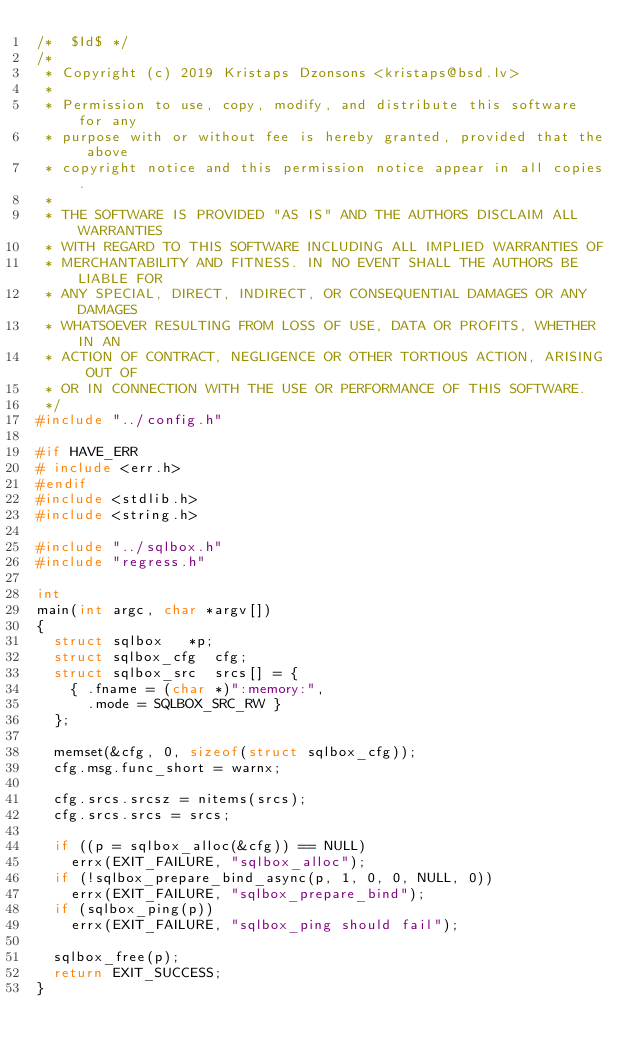Convert code to text. <code><loc_0><loc_0><loc_500><loc_500><_C_>/*	$Id$ */
/*
 * Copyright (c) 2019 Kristaps Dzonsons <kristaps@bsd.lv>
 *
 * Permission to use, copy, modify, and distribute this software for any
 * purpose with or without fee is hereby granted, provided that the above
 * copyright notice and this permission notice appear in all copies.
 *
 * THE SOFTWARE IS PROVIDED "AS IS" AND THE AUTHORS DISCLAIM ALL WARRANTIES
 * WITH REGARD TO THIS SOFTWARE INCLUDING ALL IMPLIED WARRANTIES OF
 * MERCHANTABILITY AND FITNESS. IN NO EVENT SHALL THE AUTHORS BE LIABLE FOR
 * ANY SPECIAL, DIRECT, INDIRECT, OR CONSEQUENTIAL DAMAGES OR ANY DAMAGES
 * WHATSOEVER RESULTING FROM LOSS OF USE, DATA OR PROFITS, WHETHER IN AN
 * ACTION OF CONTRACT, NEGLIGENCE OR OTHER TORTIOUS ACTION, ARISING OUT OF
 * OR IN CONNECTION WITH THE USE OR PERFORMANCE OF THIS SOFTWARE.
 */
#include "../config.h"

#if HAVE_ERR
# include <err.h>
#endif
#include <stdlib.h>
#include <string.h>

#include "../sqlbox.h"
#include "regress.h"

int
main(int argc, char *argv[])
{
	struct sqlbox		*p;
	struct sqlbox_cfg	 cfg;
	struct sqlbox_src	 srcs[] = {
		{ .fname = (char *)":memory:",
		  .mode = SQLBOX_SRC_RW }
	};

	memset(&cfg, 0, sizeof(struct sqlbox_cfg));
	cfg.msg.func_short = warnx;

	cfg.srcs.srcsz = nitems(srcs);
	cfg.srcs.srcs = srcs;

	if ((p = sqlbox_alloc(&cfg)) == NULL)
		errx(EXIT_FAILURE, "sqlbox_alloc");
	if (!sqlbox_prepare_bind_async(p, 1, 0, 0, NULL, 0))
		errx(EXIT_FAILURE, "sqlbox_prepare_bind");
	if (sqlbox_ping(p))
		errx(EXIT_FAILURE, "sqlbox_ping should fail");

	sqlbox_free(p);
	return EXIT_SUCCESS;
}
</code> 